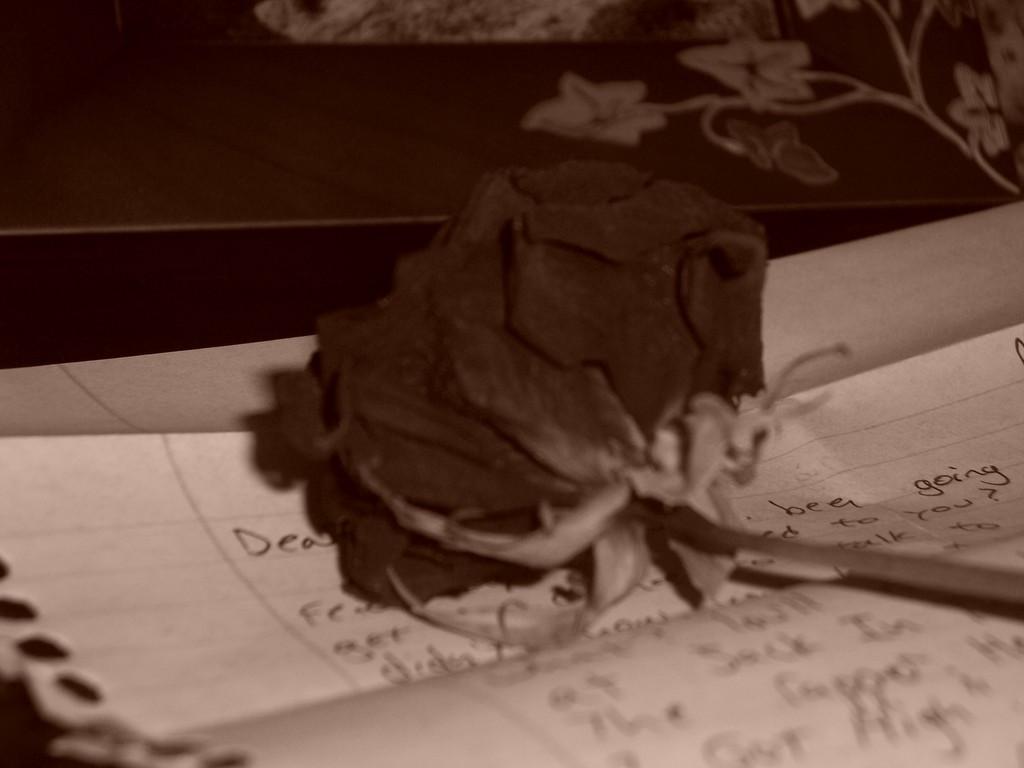How would you summarize this image in a sentence or two? As we can see in the image there is a table. On table there is a paper and flower. 